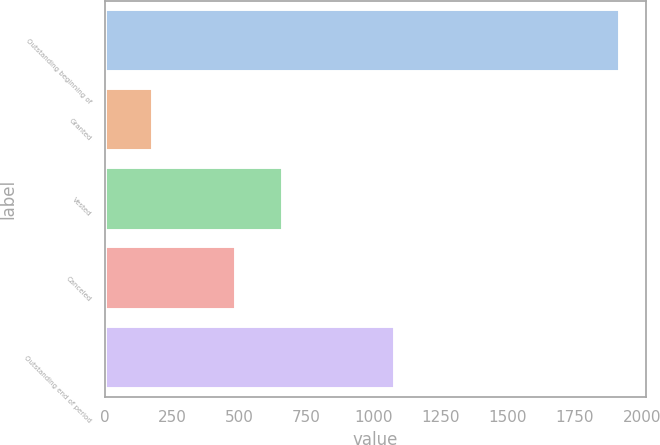Convert chart. <chart><loc_0><loc_0><loc_500><loc_500><bar_chart><fcel>Outstanding beginning of<fcel>Granted<fcel>Vested<fcel>Canceled<fcel>Outstanding end of period<nl><fcel>1920<fcel>177<fcel>663.3<fcel>489<fcel>1081<nl></chart> 